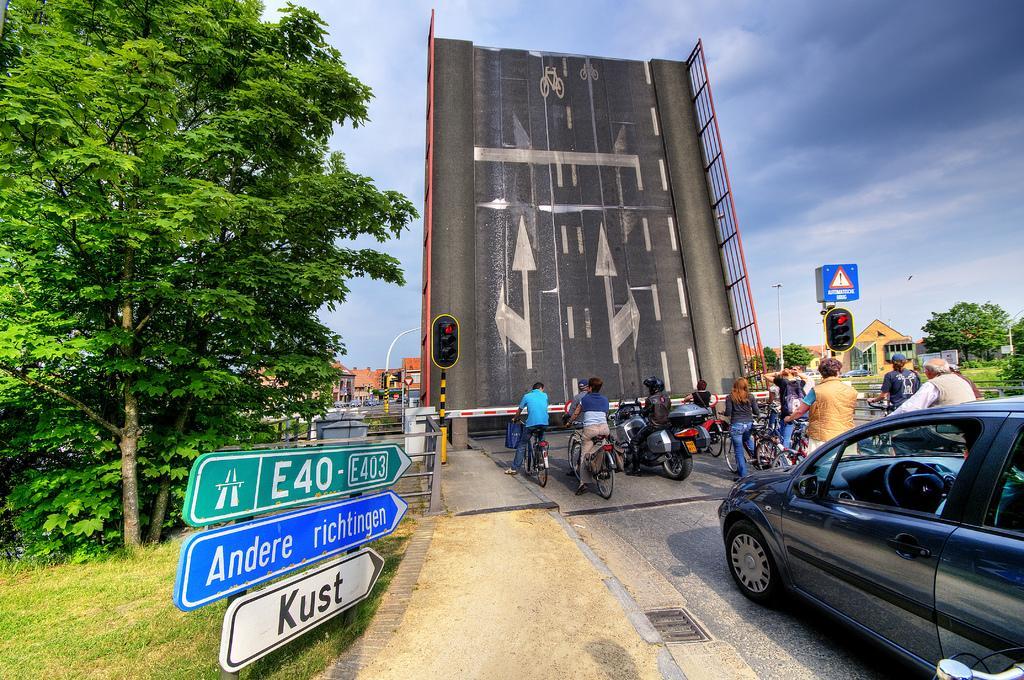Please provide a concise description of this image. In this image, on the left there are sign boards, trees, grass. In the middle there are vehicles, people, bridge, traffic signals, sign boards, poles, car. In the background there are buildings, trees, sky and clouds. 